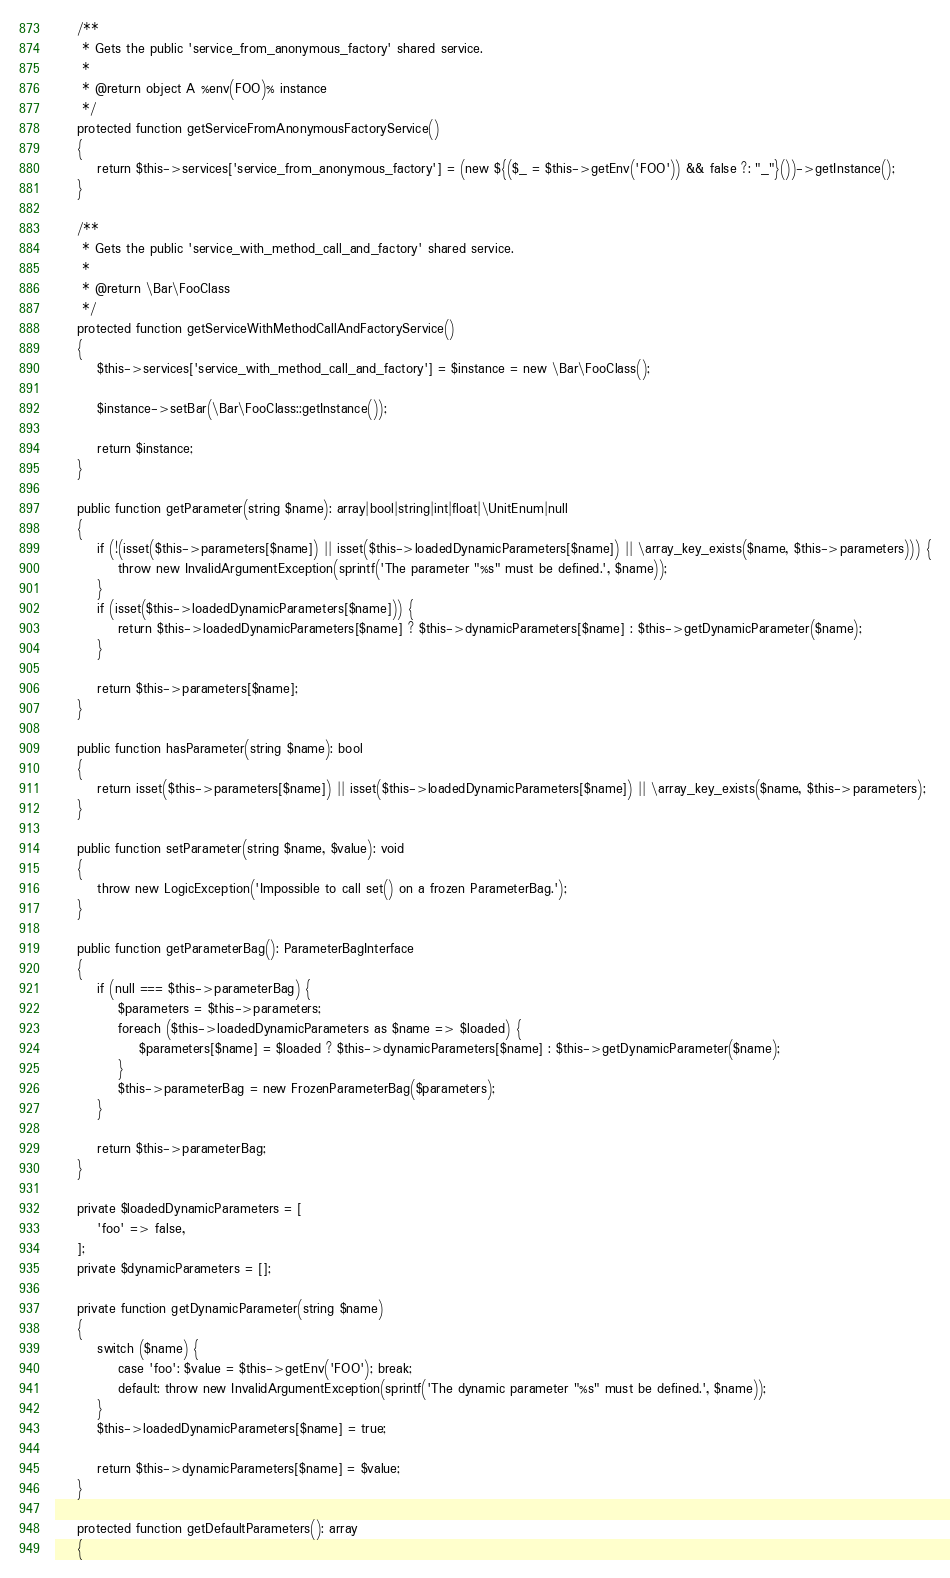Convert code to text. <code><loc_0><loc_0><loc_500><loc_500><_PHP_>    /**
     * Gets the public 'service_from_anonymous_factory' shared service.
     *
     * @return object A %env(FOO)% instance
     */
    protected function getServiceFromAnonymousFactoryService()
    {
        return $this->services['service_from_anonymous_factory'] = (new ${($_ = $this->getEnv('FOO')) && false ?: "_"}())->getInstance();
    }

    /**
     * Gets the public 'service_with_method_call_and_factory' shared service.
     *
     * @return \Bar\FooClass
     */
    protected function getServiceWithMethodCallAndFactoryService()
    {
        $this->services['service_with_method_call_and_factory'] = $instance = new \Bar\FooClass();

        $instance->setBar(\Bar\FooClass::getInstance());

        return $instance;
    }

    public function getParameter(string $name): array|bool|string|int|float|\UnitEnum|null
    {
        if (!(isset($this->parameters[$name]) || isset($this->loadedDynamicParameters[$name]) || \array_key_exists($name, $this->parameters))) {
            throw new InvalidArgumentException(sprintf('The parameter "%s" must be defined.', $name));
        }
        if (isset($this->loadedDynamicParameters[$name])) {
            return $this->loadedDynamicParameters[$name] ? $this->dynamicParameters[$name] : $this->getDynamicParameter($name);
        }

        return $this->parameters[$name];
    }

    public function hasParameter(string $name): bool
    {
        return isset($this->parameters[$name]) || isset($this->loadedDynamicParameters[$name]) || \array_key_exists($name, $this->parameters);
    }

    public function setParameter(string $name, $value): void
    {
        throw new LogicException('Impossible to call set() on a frozen ParameterBag.');
    }

    public function getParameterBag(): ParameterBagInterface
    {
        if (null === $this->parameterBag) {
            $parameters = $this->parameters;
            foreach ($this->loadedDynamicParameters as $name => $loaded) {
                $parameters[$name] = $loaded ? $this->dynamicParameters[$name] : $this->getDynamicParameter($name);
            }
            $this->parameterBag = new FrozenParameterBag($parameters);
        }

        return $this->parameterBag;
    }

    private $loadedDynamicParameters = [
        'foo' => false,
    ];
    private $dynamicParameters = [];

    private function getDynamicParameter(string $name)
    {
        switch ($name) {
            case 'foo': $value = $this->getEnv('FOO'); break;
            default: throw new InvalidArgumentException(sprintf('The dynamic parameter "%s" must be defined.', $name));
        }
        $this->loadedDynamicParameters[$name] = true;

        return $this->dynamicParameters[$name] = $value;
    }

    protected function getDefaultParameters(): array
    {</code> 